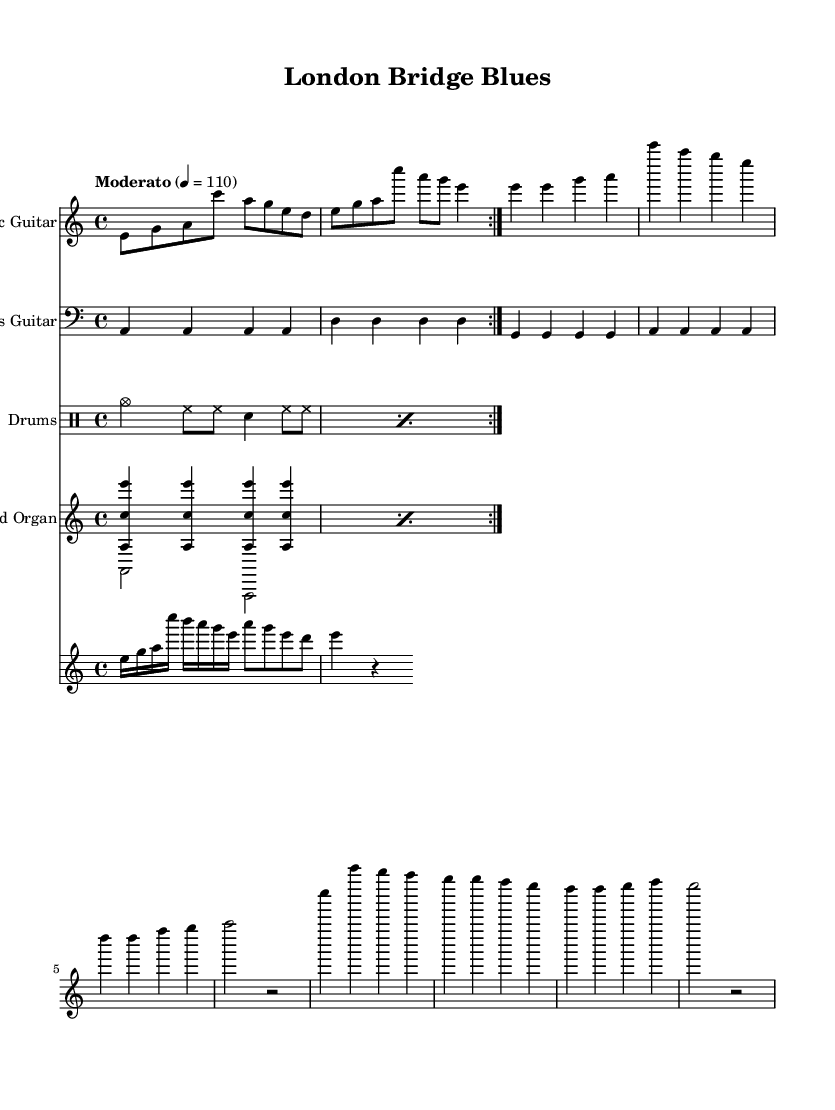What is the key signature of this music? The key signature is indicated in the global music settings section, where it is stated as "a minor". The absence of any sharps or flats next to the clef shows that the key is A minor, which contains no sharps or flats.
Answer: A minor What is the time signature of this piece? The time signature is also part of the global music settings. It is specified as "4/4", which indicates that there are four beats in each measure and a quarter note gets one beat.
Answer: 4/4 What tempo marking is given for the music? The tempo marking is noted in the global section as "Moderato" with a metronomic marking of 110. This indicates a moderate speed, commonly interpreted as walking pace.
Answer: Moderato How many bars are there in the electric guitar part? By counting the measures indicated in the electric guitar part, we can see that there are a total of 8 bars, as it consists of repeated sections along with additional lines that add up to eight measures in total.
Answer: 8 Which instruments are involved in this piece? The instruments specified in the score include Electric Guitar, Bass Guitar, Drums, Hammond Organ, and Solo Guitar. Each part is clearly labeled with its respective staff name, making it easy to identify all involved instruments.
Answer: Electric Guitar, Bass Guitar, Drums, Hammond Organ, Solo Guitar What rhythmic pattern do the drums use in the first measure? The drumming pattern in the first measure consists of four elements: cymbal, hi-hat, hi-hat, and snare, following a structured sequence. Attention to the first measure of the drum part reveals this specific pattern, which is repeated in the following measures.
Answer: cymbal, hi-hat, hi-hat, snare What techniques are suggested in the solo guitar part? The solo guitar part employs a mix of faster notes and rhythmic variation, specifically using sixteenth notes followed by eighth notes, contributing to the overall melodic embellishment typical of Blues music. The notation reflects a more dynamic use of rhythm and melody in its phrasing.
Answer: sixteenth notes and eighth notes 